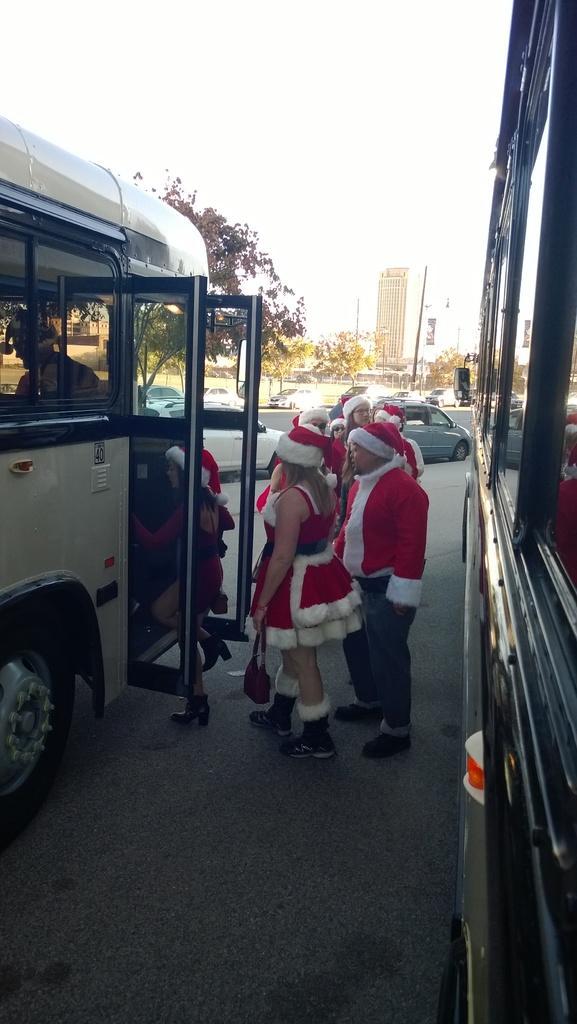Please provide a concise description of this image. These people are standing and there is a person inside a vehicle and we can see vehicles on the road. In the background we can see trees,building and sky. 